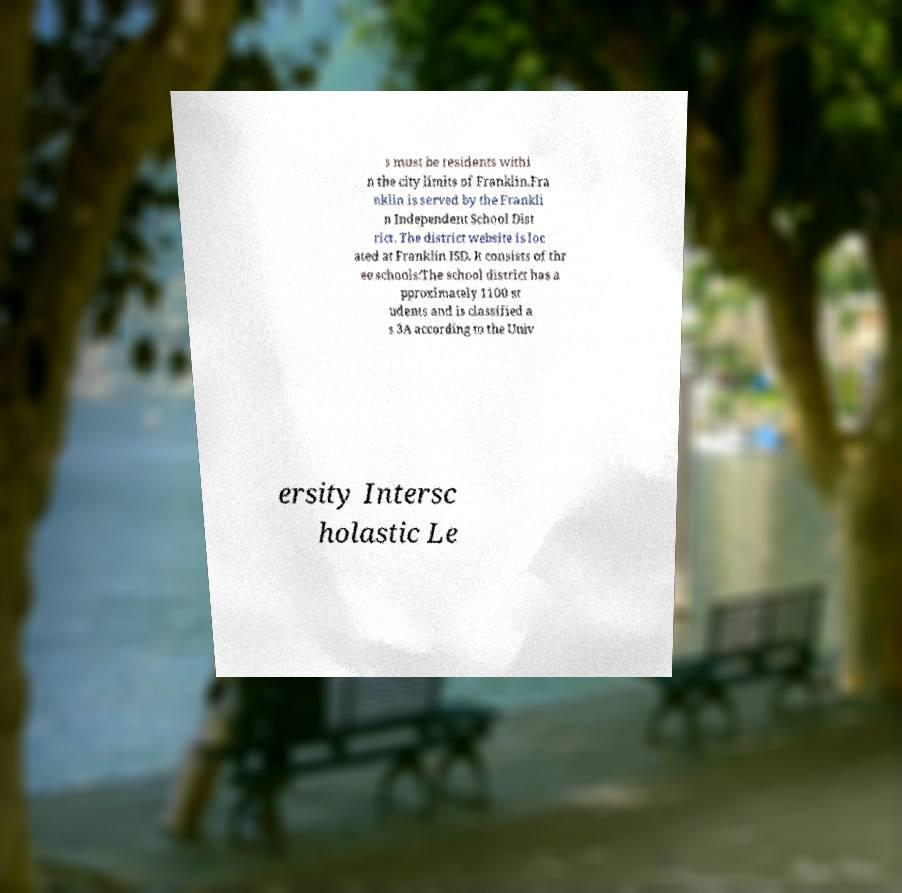What messages or text are displayed in this image? I need them in a readable, typed format. s must be residents withi n the city limits of Franklin.Fra nklin is served by the Frankli n Independent School Dist rict. The district website is loc ated at Franklin ISD. It consists of thr ee schools:The school district has a pproximately 1100 st udents and is classified a s 3A according to the Univ ersity Intersc holastic Le 